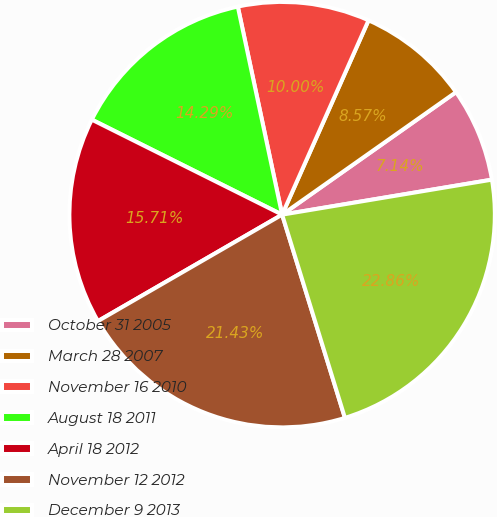Convert chart. <chart><loc_0><loc_0><loc_500><loc_500><pie_chart><fcel>October 31 2005<fcel>March 28 2007<fcel>November 16 2010<fcel>August 18 2011<fcel>April 18 2012<fcel>November 12 2012<fcel>December 9 2013<nl><fcel>7.14%<fcel>8.57%<fcel>10.0%<fcel>14.29%<fcel>15.71%<fcel>21.43%<fcel>22.86%<nl></chart> 